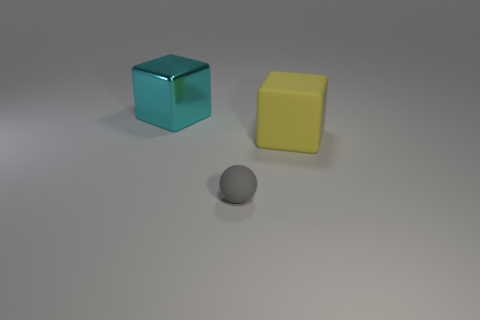How many objects are large gray cylinders or gray rubber balls?
Offer a very short reply. 1. Is the shape of the big yellow thing the same as the tiny rubber thing?
Offer a terse response. No. Are there any balls made of the same material as the yellow block?
Provide a short and direct response. Yes. Is there a object to the right of the cube behind the large rubber thing?
Make the answer very short. Yes. There is a matte object that is right of the gray object; is its size the same as the gray matte thing?
Offer a terse response. No. How big is the cyan shiny cube?
Ensure brevity in your answer.  Large. How many tiny objects are gray balls or brown cylinders?
Keep it short and to the point. 1. What is the size of the object that is both on the left side of the big yellow thing and behind the gray matte thing?
Provide a succinct answer. Large. What number of tiny matte objects are in front of the cyan shiny cube?
Provide a succinct answer. 1. What shape is the thing that is both to the left of the large yellow block and behind the tiny gray rubber thing?
Provide a succinct answer. Cube. 